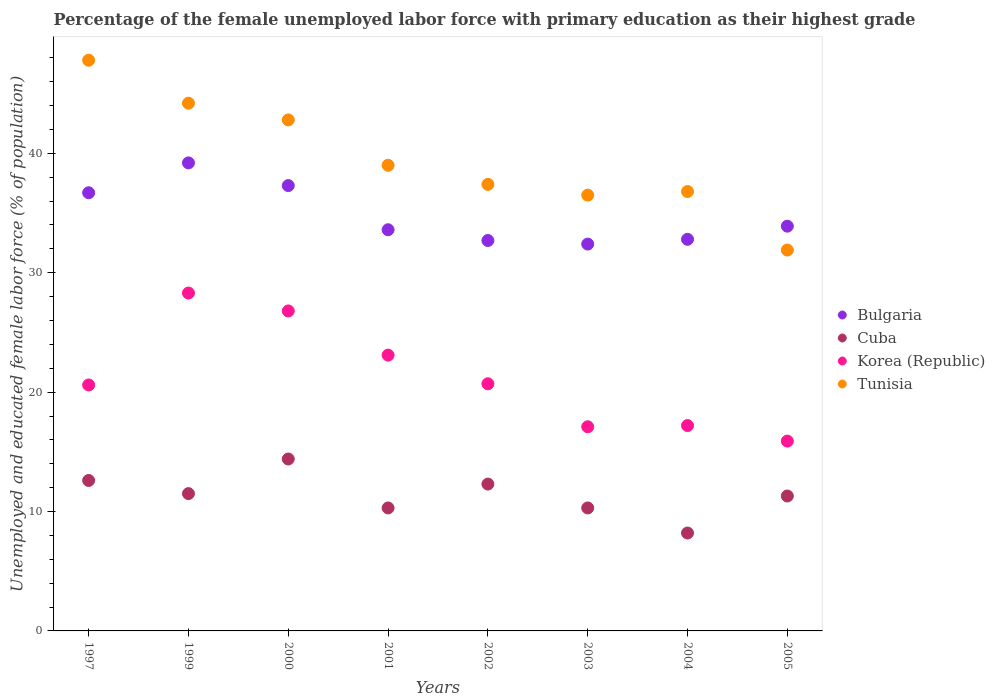Is the number of dotlines equal to the number of legend labels?
Your answer should be very brief. Yes. What is the percentage of the unemployed female labor force with primary education in Tunisia in 2003?
Your answer should be very brief. 36.5. Across all years, what is the maximum percentage of the unemployed female labor force with primary education in Cuba?
Keep it short and to the point. 14.4. Across all years, what is the minimum percentage of the unemployed female labor force with primary education in Bulgaria?
Give a very brief answer. 32.4. What is the total percentage of the unemployed female labor force with primary education in Bulgaria in the graph?
Offer a terse response. 278.6. What is the difference between the percentage of the unemployed female labor force with primary education in Bulgaria in 2004 and that in 2005?
Make the answer very short. -1.1. What is the average percentage of the unemployed female labor force with primary education in Korea (Republic) per year?
Give a very brief answer. 21.21. In the year 2005, what is the difference between the percentage of the unemployed female labor force with primary education in Cuba and percentage of the unemployed female labor force with primary education in Korea (Republic)?
Make the answer very short. -4.6. What is the ratio of the percentage of the unemployed female labor force with primary education in Korea (Republic) in 1999 to that in 2003?
Provide a succinct answer. 1.65. What is the difference between the highest and the second highest percentage of the unemployed female labor force with primary education in Cuba?
Make the answer very short. 1.8. What is the difference between the highest and the lowest percentage of the unemployed female labor force with primary education in Bulgaria?
Ensure brevity in your answer.  6.8. In how many years, is the percentage of the unemployed female labor force with primary education in Cuba greater than the average percentage of the unemployed female labor force with primary education in Cuba taken over all years?
Give a very brief answer. 4. Is it the case that in every year, the sum of the percentage of the unemployed female labor force with primary education in Korea (Republic) and percentage of the unemployed female labor force with primary education in Bulgaria  is greater than the sum of percentage of the unemployed female labor force with primary education in Tunisia and percentage of the unemployed female labor force with primary education in Cuba?
Your answer should be very brief. Yes. Is it the case that in every year, the sum of the percentage of the unemployed female labor force with primary education in Bulgaria and percentage of the unemployed female labor force with primary education in Tunisia  is greater than the percentage of the unemployed female labor force with primary education in Cuba?
Provide a short and direct response. Yes. Does the percentage of the unemployed female labor force with primary education in Bulgaria monotonically increase over the years?
Make the answer very short. No. Is the percentage of the unemployed female labor force with primary education in Cuba strictly greater than the percentage of the unemployed female labor force with primary education in Korea (Republic) over the years?
Make the answer very short. No. Is the percentage of the unemployed female labor force with primary education in Bulgaria strictly less than the percentage of the unemployed female labor force with primary education in Tunisia over the years?
Provide a short and direct response. No. How many dotlines are there?
Offer a very short reply. 4. How many years are there in the graph?
Give a very brief answer. 8. What is the difference between two consecutive major ticks on the Y-axis?
Keep it short and to the point. 10. Does the graph contain any zero values?
Provide a succinct answer. No. What is the title of the graph?
Give a very brief answer. Percentage of the female unemployed labor force with primary education as their highest grade. Does "Micronesia" appear as one of the legend labels in the graph?
Ensure brevity in your answer.  No. What is the label or title of the X-axis?
Ensure brevity in your answer.  Years. What is the label or title of the Y-axis?
Give a very brief answer. Unemployed and educated female labor force (% of population). What is the Unemployed and educated female labor force (% of population) of Bulgaria in 1997?
Make the answer very short. 36.7. What is the Unemployed and educated female labor force (% of population) of Cuba in 1997?
Offer a terse response. 12.6. What is the Unemployed and educated female labor force (% of population) of Korea (Republic) in 1997?
Your answer should be compact. 20.6. What is the Unemployed and educated female labor force (% of population) in Tunisia in 1997?
Offer a very short reply. 47.8. What is the Unemployed and educated female labor force (% of population) in Bulgaria in 1999?
Keep it short and to the point. 39.2. What is the Unemployed and educated female labor force (% of population) of Korea (Republic) in 1999?
Offer a very short reply. 28.3. What is the Unemployed and educated female labor force (% of population) in Tunisia in 1999?
Provide a short and direct response. 44.2. What is the Unemployed and educated female labor force (% of population) in Bulgaria in 2000?
Keep it short and to the point. 37.3. What is the Unemployed and educated female labor force (% of population) of Cuba in 2000?
Your answer should be very brief. 14.4. What is the Unemployed and educated female labor force (% of population) of Korea (Republic) in 2000?
Offer a very short reply. 26.8. What is the Unemployed and educated female labor force (% of population) in Tunisia in 2000?
Make the answer very short. 42.8. What is the Unemployed and educated female labor force (% of population) of Bulgaria in 2001?
Ensure brevity in your answer.  33.6. What is the Unemployed and educated female labor force (% of population) of Cuba in 2001?
Provide a short and direct response. 10.3. What is the Unemployed and educated female labor force (% of population) in Korea (Republic) in 2001?
Provide a short and direct response. 23.1. What is the Unemployed and educated female labor force (% of population) of Tunisia in 2001?
Make the answer very short. 39. What is the Unemployed and educated female labor force (% of population) of Bulgaria in 2002?
Keep it short and to the point. 32.7. What is the Unemployed and educated female labor force (% of population) in Cuba in 2002?
Keep it short and to the point. 12.3. What is the Unemployed and educated female labor force (% of population) of Korea (Republic) in 2002?
Provide a succinct answer. 20.7. What is the Unemployed and educated female labor force (% of population) of Tunisia in 2002?
Ensure brevity in your answer.  37.4. What is the Unemployed and educated female labor force (% of population) of Bulgaria in 2003?
Offer a terse response. 32.4. What is the Unemployed and educated female labor force (% of population) in Cuba in 2003?
Provide a short and direct response. 10.3. What is the Unemployed and educated female labor force (% of population) in Korea (Republic) in 2003?
Your answer should be very brief. 17.1. What is the Unemployed and educated female labor force (% of population) of Tunisia in 2003?
Offer a very short reply. 36.5. What is the Unemployed and educated female labor force (% of population) of Bulgaria in 2004?
Your answer should be very brief. 32.8. What is the Unemployed and educated female labor force (% of population) of Cuba in 2004?
Keep it short and to the point. 8.2. What is the Unemployed and educated female labor force (% of population) in Korea (Republic) in 2004?
Your answer should be compact. 17.2. What is the Unemployed and educated female labor force (% of population) of Tunisia in 2004?
Your answer should be compact. 36.8. What is the Unemployed and educated female labor force (% of population) of Bulgaria in 2005?
Make the answer very short. 33.9. What is the Unemployed and educated female labor force (% of population) in Cuba in 2005?
Make the answer very short. 11.3. What is the Unemployed and educated female labor force (% of population) of Korea (Republic) in 2005?
Offer a very short reply. 15.9. What is the Unemployed and educated female labor force (% of population) of Tunisia in 2005?
Your answer should be compact. 31.9. Across all years, what is the maximum Unemployed and educated female labor force (% of population) in Bulgaria?
Ensure brevity in your answer.  39.2. Across all years, what is the maximum Unemployed and educated female labor force (% of population) of Cuba?
Make the answer very short. 14.4. Across all years, what is the maximum Unemployed and educated female labor force (% of population) in Korea (Republic)?
Keep it short and to the point. 28.3. Across all years, what is the maximum Unemployed and educated female labor force (% of population) in Tunisia?
Your answer should be very brief. 47.8. Across all years, what is the minimum Unemployed and educated female labor force (% of population) in Bulgaria?
Give a very brief answer. 32.4. Across all years, what is the minimum Unemployed and educated female labor force (% of population) in Cuba?
Give a very brief answer. 8.2. Across all years, what is the minimum Unemployed and educated female labor force (% of population) of Korea (Republic)?
Your answer should be very brief. 15.9. Across all years, what is the minimum Unemployed and educated female labor force (% of population) of Tunisia?
Your response must be concise. 31.9. What is the total Unemployed and educated female labor force (% of population) in Bulgaria in the graph?
Keep it short and to the point. 278.6. What is the total Unemployed and educated female labor force (% of population) of Cuba in the graph?
Offer a terse response. 90.9. What is the total Unemployed and educated female labor force (% of population) of Korea (Republic) in the graph?
Your response must be concise. 169.7. What is the total Unemployed and educated female labor force (% of population) of Tunisia in the graph?
Your response must be concise. 316.4. What is the difference between the Unemployed and educated female labor force (% of population) in Cuba in 1997 and that in 1999?
Your answer should be compact. 1.1. What is the difference between the Unemployed and educated female labor force (% of population) of Korea (Republic) in 1997 and that in 1999?
Your answer should be compact. -7.7. What is the difference between the Unemployed and educated female labor force (% of population) of Tunisia in 1997 and that in 1999?
Offer a terse response. 3.6. What is the difference between the Unemployed and educated female labor force (% of population) in Bulgaria in 1997 and that in 2000?
Your answer should be compact. -0.6. What is the difference between the Unemployed and educated female labor force (% of population) in Cuba in 1997 and that in 2000?
Your response must be concise. -1.8. What is the difference between the Unemployed and educated female labor force (% of population) of Bulgaria in 1997 and that in 2001?
Offer a terse response. 3.1. What is the difference between the Unemployed and educated female labor force (% of population) in Cuba in 1997 and that in 2001?
Offer a very short reply. 2.3. What is the difference between the Unemployed and educated female labor force (% of population) of Bulgaria in 1997 and that in 2002?
Provide a succinct answer. 4. What is the difference between the Unemployed and educated female labor force (% of population) in Cuba in 1997 and that in 2002?
Offer a terse response. 0.3. What is the difference between the Unemployed and educated female labor force (% of population) in Bulgaria in 1997 and that in 2003?
Offer a very short reply. 4.3. What is the difference between the Unemployed and educated female labor force (% of population) of Cuba in 1997 and that in 2003?
Offer a terse response. 2.3. What is the difference between the Unemployed and educated female labor force (% of population) of Tunisia in 1997 and that in 2003?
Provide a short and direct response. 11.3. What is the difference between the Unemployed and educated female labor force (% of population) in Cuba in 1997 and that in 2004?
Your answer should be compact. 4.4. What is the difference between the Unemployed and educated female labor force (% of population) of Tunisia in 1997 and that in 2004?
Provide a short and direct response. 11. What is the difference between the Unemployed and educated female labor force (% of population) of Cuba in 1997 and that in 2005?
Ensure brevity in your answer.  1.3. What is the difference between the Unemployed and educated female labor force (% of population) of Korea (Republic) in 1997 and that in 2005?
Offer a terse response. 4.7. What is the difference between the Unemployed and educated female labor force (% of population) of Tunisia in 1997 and that in 2005?
Make the answer very short. 15.9. What is the difference between the Unemployed and educated female labor force (% of population) of Tunisia in 1999 and that in 2000?
Your response must be concise. 1.4. What is the difference between the Unemployed and educated female labor force (% of population) of Bulgaria in 1999 and that in 2001?
Provide a short and direct response. 5.6. What is the difference between the Unemployed and educated female labor force (% of population) of Tunisia in 1999 and that in 2001?
Your answer should be very brief. 5.2. What is the difference between the Unemployed and educated female labor force (% of population) in Bulgaria in 1999 and that in 2002?
Your answer should be very brief. 6.5. What is the difference between the Unemployed and educated female labor force (% of population) in Tunisia in 1999 and that in 2002?
Your response must be concise. 6.8. What is the difference between the Unemployed and educated female labor force (% of population) of Bulgaria in 1999 and that in 2003?
Your response must be concise. 6.8. What is the difference between the Unemployed and educated female labor force (% of population) in Korea (Republic) in 1999 and that in 2003?
Make the answer very short. 11.2. What is the difference between the Unemployed and educated female labor force (% of population) of Cuba in 1999 and that in 2004?
Provide a short and direct response. 3.3. What is the difference between the Unemployed and educated female labor force (% of population) of Korea (Republic) in 1999 and that in 2004?
Offer a terse response. 11.1. What is the difference between the Unemployed and educated female labor force (% of population) of Tunisia in 1999 and that in 2004?
Provide a succinct answer. 7.4. What is the difference between the Unemployed and educated female labor force (% of population) in Bulgaria in 1999 and that in 2005?
Keep it short and to the point. 5.3. What is the difference between the Unemployed and educated female labor force (% of population) of Tunisia in 1999 and that in 2005?
Make the answer very short. 12.3. What is the difference between the Unemployed and educated female labor force (% of population) in Cuba in 2000 and that in 2001?
Your answer should be very brief. 4.1. What is the difference between the Unemployed and educated female labor force (% of population) of Korea (Republic) in 2000 and that in 2001?
Ensure brevity in your answer.  3.7. What is the difference between the Unemployed and educated female labor force (% of population) in Tunisia in 2000 and that in 2001?
Your response must be concise. 3.8. What is the difference between the Unemployed and educated female labor force (% of population) in Cuba in 2000 and that in 2002?
Give a very brief answer. 2.1. What is the difference between the Unemployed and educated female labor force (% of population) in Korea (Republic) in 2000 and that in 2002?
Provide a short and direct response. 6.1. What is the difference between the Unemployed and educated female labor force (% of population) in Tunisia in 2000 and that in 2002?
Give a very brief answer. 5.4. What is the difference between the Unemployed and educated female labor force (% of population) of Bulgaria in 2000 and that in 2003?
Give a very brief answer. 4.9. What is the difference between the Unemployed and educated female labor force (% of population) of Cuba in 2000 and that in 2003?
Provide a short and direct response. 4.1. What is the difference between the Unemployed and educated female labor force (% of population) in Cuba in 2000 and that in 2004?
Offer a terse response. 6.2. What is the difference between the Unemployed and educated female labor force (% of population) in Korea (Republic) in 2000 and that in 2004?
Your answer should be compact. 9.6. What is the difference between the Unemployed and educated female labor force (% of population) in Bulgaria in 2000 and that in 2005?
Ensure brevity in your answer.  3.4. What is the difference between the Unemployed and educated female labor force (% of population) of Korea (Republic) in 2000 and that in 2005?
Keep it short and to the point. 10.9. What is the difference between the Unemployed and educated female labor force (% of population) of Cuba in 2001 and that in 2002?
Keep it short and to the point. -2. What is the difference between the Unemployed and educated female labor force (% of population) of Korea (Republic) in 2001 and that in 2002?
Provide a succinct answer. 2.4. What is the difference between the Unemployed and educated female labor force (% of population) in Tunisia in 2001 and that in 2002?
Offer a very short reply. 1.6. What is the difference between the Unemployed and educated female labor force (% of population) of Cuba in 2001 and that in 2003?
Make the answer very short. 0. What is the difference between the Unemployed and educated female labor force (% of population) of Tunisia in 2001 and that in 2003?
Offer a terse response. 2.5. What is the difference between the Unemployed and educated female labor force (% of population) of Tunisia in 2001 and that in 2004?
Give a very brief answer. 2.2. What is the difference between the Unemployed and educated female labor force (% of population) in Korea (Republic) in 2001 and that in 2005?
Ensure brevity in your answer.  7.2. What is the difference between the Unemployed and educated female labor force (% of population) in Cuba in 2002 and that in 2003?
Ensure brevity in your answer.  2. What is the difference between the Unemployed and educated female labor force (% of population) of Korea (Republic) in 2002 and that in 2003?
Ensure brevity in your answer.  3.6. What is the difference between the Unemployed and educated female labor force (% of population) in Bulgaria in 2002 and that in 2004?
Ensure brevity in your answer.  -0.1. What is the difference between the Unemployed and educated female labor force (% of population) in Korea (Republic) in 2002 and that in 2004?
Offer a very short reply. 3.5. What is the difference between the Unemployed and educated female labor force (% of population) in Bulgaria in 2003 and that in 2004?
Make the answer very short. -0.4. What is the difference between the Unemployed and educated female labor force (% of population) in Korea (Republic) in 2003 and that in 2004?
Give a very brief answer. -0.1. What is the difference between the Unemployed and educated female labor force (% of population) of Cuba in 2004 and that in 2005?
Provide a succinct answer. -3.1. What is the difference between the Unemployed and educated female labor force (% of population) in Korea (Republic) in 2004 and that in 2005?
Offer a very short reply. 1.3. What is the difference between the Unemployed and educated female labor force (% of population) of Tunisia in 2004 and that in 2005?
Your answer should be compact. 4.9. What is the difference between the Unemployed and educated female labor force (% of population) in Bulgaria in 1997 and the Unemployed and educated female labor force (% of population) in Cuba in 1999?
Give a very brief answer. 25.2. What is the difference between the Unemployed and educated female labor force (% of population) in Bulgaria in 1997 and the Unemployed and educated female labor force (% of population) in Korea (Republic) in 1999?
Ensure brevity in your answer.  8.4. What is the difference between the Unemployed and educated female labor force (% of population) of Bulgaria in 1997 and the Unemployed and educated female labor force (% of population) of Tunisia in 1999?
Keep it short and to the point. -7.5. What is the difference between the Unemployed and educated female labor force (% of population) in Cuba in 1997 and the Unemployed and educated female labor force (% of population) in Korea (Republic) in 1999?
Offer a very short reply. -15.7. What is the difference between the Unemployed and educated female labor force (% of population) in Cuba in 1997 and the Unemployed and educated female labor force (% of population) in Tunisia in 1999?
Offer a very short reply. -31.6. What is the difference between the Unemployed and educated female labor force (% of population) of Korea (Republic) in 1997 and the Unemployed and educated female labor force (% of population) of Tunisia in 1999?
Keep it short and to the point. -23.6. What is the difference between the Unemployed and educated female labor force (% of population) of Bulgaria in 1997 and the Unemployed and educated female labor force (% of population) of Cuba in 2000?
Make the answer very short. 22.3. What is the difference between the Unemployed and educated female labor force (% of population) of Bulgaria in 1997 and the Unemployed and educated female labor force (% of population) of Korea (Republic) in 2000?
Provide a succinct answer. 9.9. What is the difference between the Unemployed and educated female labor force (% of population) in Bulgaria in 1997 and the Unemployed and educated female labor force (% of population) in Tunisia in 2000?
Offer a very short reply. -6.1. What is the difference between the Unemployed and educated female labor force (% of population) of Cuba in 1997 and the Unemployed and educated female labor force (% of population) of Korea (Republic) in 2000?
Your answer should be compact. -14.2. What is the difference between the Unemployed and educated female labor force (% of population) of Cuba in 1997 and the Unemployed and educated female labor force (% of population) of Tunisia in 2000?
Provide a succinct answer. -30.2. What is the difference between the Unemployed and educated female labor force (% of population) in Korea (Republic) in 1997 and the Unemployed and educated female labor force (% of population) in Tunisia in 2000?
Provide a succinct answer. -22.2. What is the difference between the Unemployed and educated female labor force (% of population) of Bulgaria in 1997 and the Unemployed and educated female labor force (% of population) of Cuba in 2001?
Your response must be concise. 26.4. What is the difference between the Unemployed and educated female labor force (% of population) of Bulgaria in 1997 and the Unemployed and educated female labor force (% of population) of Korea (Republic) in 2001?
Give a very brief answer. 13.6. What is the difference between the Unemployed and educated female labor force (% of population) in Cuba in 1997 and the Unemployed and educated female labor force (% of population) in Tunisia in 2001?
Provide a short and direct response. -26.4. What is the difference between the Unemployed and educated female labor force (% of population) in Korea (Republic) in 1997 and the Unemployed and educated female labor force (% of population) in Tunisia in 2001?
Ensure brevity in your answer.  -18.4. What is the difference between the Unemployed and educated female labor force (% of population) of Bulgaria in 1997 and the Unemployed and educated female labor force (% of population) of Cuba in 2002?
Your response must be concise. 24.4. What is the difference between the Unemployed and educated female labor force (% of population) in Bulgaria in 1997 and the Unemployed and educated female labor force (% of population) in Korea (Republic) in 2002?
Make the answer very short. 16. What is the difference between the Unemployed and educated female labor force (% of population) of Cuba in 1997 and the Unemployed and educated female labor force (% of population) of Korea (Republic) in 2002?
Keep it short and to the point. -8.1. What is the difference between the Unemployed and educated female labor force (% of population) in Cuba in 1997 and the Unemployed and educated female labor force (% of population) in Tunisia in 2002?
Provide a succinct answer. -24.8. What is the difference between the Unemployed and educated female labor force (% of population) in Korea (Republic) in 1997 and the Unemployed and educated female labor force (% of population) in Tunisia in 2002?
Your response must be concise. -16.8. What is the difference between the Unemployed and educated female labor force (% of population) in Bulgaria in 1997 and the Unemployed and educated female labor force (% of population) in Cuba in 2003?
Ensure brevity in your answer.  26.4. What is the difference between the Unemployed and educated female labor force (% of population) of Bulgaria in 1997 and the Unemployed and educated female labor force (% of population) of Korea (Republic) in 2003?
Your response must be concise. 19.6. What is the difference between the Unemployed and educated female labor force (% of population) of Cuba in 1997 and the Unemployed and educated female labor force (% of population) of Tunisia in 2003?
Provide a short and direct response. -23.9. What is the difference between the Unemployed and educated female labor force (% of population) in Korea (Republic) in 1997 and the Unemployed and educated female labor force (% of population) in Tunisia in 2003?
Give a very brief answer. -15.9. What is the difference between the Unemployed and educated female labor force (% of population) in Bulgaria in 1997 and the Unemployed and educated female labor force (% of population) in Cuba in 2004?
Offer a very short reply. 28.5. What is the difference between the Unemployed and educated female labor force (% of population) in Bulgaria in 1997 and the Unemployed and educated female labor force (% of population) in Korea (Republic) in 2004?
Provide a short and direct response. 19.5. What is the difference between the Unemployed and educated female labor force (% of population) of Bulgaria in 1997 and the Unemployed and educated female labor force (% of population) of Tunisia in 2004?
Provide a short and direct response. -0.1. What is the difference between the Unemployed and educated female labor force (% of population) in Cuba in 1997 and the Unemployed and educated female labor force (% of population) in Tunisia in 2004?
Ensure brevity in your answer.  -24.2. What is the difference between the Unemployed and educated female labor force (% of population) of Korea (Republic) in 1997 and the Unemployed and educated female labor force (% of population) of Tunisia in 2004?
Provide a short and direct response. -16.2. What is the difference between the Unemployed and educated female labor force (% of population) in Bulgaria in 1997 and the Unemployed and educated female labor force (% of population) in Cuba in 2005?
Your answer should be very brief. 25.4. What is the difference between the Unemployed and educated female labor force (% of population) in Bulgaria in 1997 and the Unemployed and educated female labor force (% of population) in Korea (Republic) in 2005?
Keep it short and to the point. 20.8. What is the difference between the Unemployed and educated female labor force (% of population) in Cuba in 1997 and the Unemployed and educated female labor force (% of population) in Tunisia in 2005?
Keep it short and to the point. -19.3. What is the difference between the Unemployed and educated female labor force (% of population) of Bulgaria in 1999 and the Unemployed and educated female labor force (% of population) of Cuba in 2000?
Your response must be concise. 24.8. What is the difference between the Unemployed and educated female labor force (% of population) of Bulgaria in 1999 and the Unemployed and educated female labor force (% of population) of Tunisia in 2000?
Your answer should be very brief. -3.6. What is the difference between the Unemployed and educated female labor force (% of population) of Cuba in 1999 and the Unemployed and educated female labor force (% of population) of Korea (Republic) in 2000?
Your answer should be very brief. -15.3. What is the difference between the Unemployed and educated female labor force (% of population) in Cuba in 1999 and the Unemployed and educated female labor force (% of population) in Tunisia in 2000?
Keep it short and to the point. -31.3. What is the difference between the Unemployed and educated female labor force (% of population) of Korea (Republic) in 1999 and the Unemployed and educated female labor force (% of population) of Tunisia in 2000?
Your answer should be very brief. -14.5. What is the difference between the Unemployed and educated female labor force (% of population) of Bulgaria in 1999 and the Unemployed and educated female labor force (% of population) of Cuba in 2001?
Make the answer very short. 28.9. What is the difference between the Unemployed and educated female labor force (% of population) of Bulgaria in 1999 and the Unemployed and educated female labor force (% of population) of Korea (Republic) in 2001?
Provide a short and direct response. 16.1. What is the difference between the Unemployed and educated female labor force (% of population) of Cuba in 1999 and the Unemployed and educated female labor force (% of population) of Tunisia in 2001?
Make the answer very short. -27.5. What is the difference between the Unemployed and educated female labor force (% of population) of Korea (Republic) in 1999 and the Unemployed and educated female labor force (% of population) of Tunisia in 2001?
Ensure brevity in your answer.  -10.7. What is the difference between the Unemployed and educated female labor force (% of population) of Bulgaria in 1999 and the Unemployed and educated female labor force (% of population) of Cuba in 2002?
Your answer should be compact. 26.9. What is the difference between the Unemployed and educated female labor force (% of population) of Bulgaria in 1999 and the Unemployed and educated female labor force (% of population) of Korea (Republic) in 2002?
Provide a short and direct response. 18.5. What is the difference between the Unemployed and educated female labor force (% of population) in Bulgaria in 1999 and the Unemployed and educated female labor force (% of population) in Tunisia in 2002?
Provide a short and direct response. 1.8. What is the difference between the Unemployed and educated female labor force (% of population) of Cuba in 1999 and the Unemployed and educated female labor force (% of population) of Tunisia in 2002?
Keep it short and to the point. -25.9. What is the difference between the Unemployed and educated female labor force (% of population) of Korea (Republic) in 1999 and the Unemployed and educated female labor force (% of population) of Tunisia in 2002?
Your response must be concise. -9.1. What is the difference between the Unemployed and educated female labor force (% of population) in Bulgaria in 1999 and the Unemployed and educated female labor force (% of population) in Cuba in 2003?
Ensure brevity in your answer.  28.9. What is the difference between the Unemployed and educated female labor force (% of population) of Bulgaria in 1999 and the Unemployed and educated female labor force (% of population) of Korea (Republic) in 2003?
Your answer should be compact. 22.1. What is the difference between the Unemployed and educated female labor force (% of population) of Bulgaria in 1999 and the Unemployed and educated female labor force (% of population) of Tunisia in 2003?
Offer a terse response. 2.7. What is the difference between the Unemployed and educated female labor force (% of population) of Cuba in 1999 and the Unemployed and educated female labor force (% of population) of Korea (Republic) in 2003?
Your answer should be compact. -5.6. What is the difference between the Unemployed and educated female labor force (% of population) of Korea (Republic) in 1999 and the Unemployed and educated female labor force (% of population) of Tunisia in 2003?
Your answer should be very brief. -8.2. What is the difference between the Unemployed and educated female labor force (% of population) of Cuba in 1999 and the Unemployed and educated female labor force (% of population) of Tunisia in 2004?
Make the answer very short. -25.3. What is the difference between the Unemployed and educated female labor force (% of population) of Bulgaria in 1999 and the Unemployed and educated female labor force (% of population) of Cuba in 2005?
Your response must be concise. 27.9. What is the difference between the Unemployed and educated female labor force (% of population) in Bulgaria in 1999 and the Unemployed and educated female labor force (% of population) in Korea (Republic) in 2005?
Your answer should be compact. 23.3. What is the difference between the Unemployed and educated female labor force (% of population) in Cuba in 1999 and the Unemployed and educated female labor force (% of population) in Korea (Republic) in 2005?
Your answer should be compact. -4.4. What is the difference between the Unemployed and educated female labor force (% of population) of Cuba in 1999 and the Unemployed and educated female labor force (% of population) of Tunisia in 2005?
Keep it short and to the point. -20.4. What is the difference between the Unemployed and educated female labor force (% of population) of Korea (Republic) in 1999 and the Unemployed and educated female labor force (% of population) of Tunisia in 2005?
Your answer should be very brief. -3.6. What is the difference between the Unemployed and educated female labor force (% of population) of Bulgaria in 2000 and the Unemployed and educated female labor force (% of population) of Korea (Republic) in 2001?
Offer a very short reply. 14.2. What is the difference between the Unemployed and educated female labor force (% of population) of Cuba in 2000 and the Unemployed and educated female labor force (% of population) of Tunisia in 2001?
Keep it short and to the point. -24.6. What is the difference between the Unemployed and educated female labor force (% of population) in Bulgaria in 2000 and the Unemployed and educated female labor force (% of population) in Korea (Republic) in 2002?
Provide a short and direct response. 16.6. What is the difference between the Unemployed and educated female labor force (% of population) in Bulgaria in 2000 and the Unemployed and educated female labor force (% of population) in Tunisia in 2002?
Offer a terse response. -0.1. What is the difference between the Unemployed and educated female labor force (% of population) of Korea (Republic) in 2000 and the Unemployed and educated female labor force (% of population) of Tunisia in 2002?
Provide a short and direct response. -10.6. What is the difference between the Unemployed and educated female labor force (% of population) in Bulgaria in 2000 and the Unemployed and educated female labor force (% of population) in Korea (Republic) in 2003?
Your answer should be compact. 20.2. What is the difference between the Unemployed and educated female labor force (% of population) of Cuba in 2000 and the Unemployed and educated female labor force (% of population) of Korea (Republic) in 2003?
Your answer should be very brief. -2.7. What is the difference between the Unemployed and educated female labor force (% of population) in Cuba in 2000 and the Unemployed and educated female labor force (% of population) in Tunisia in 2003?
Ensure brevity in your answer.  -22.1. What is the difference between the Unemployed and educated female labor force (% of population) of Korea (Republic) in 2000 and the Unemployed and educated female labor force (% of population) of Tunisia in 2003?
Offer a terse response. -9.7. What is the difference between the Unemployed and educated female labor force (% of population) in Bulgaria in 2000 and the Unemployed and educated female labor force (% of population) in Cuba in 2004?
Make the answer very short. 29.1. What is the difference between the Unemployed and educated female labor force (% of population) of Bulgaria in 2000 and the Unemployed and educated female labor force (% of population) of Korea (Republic) in 2004?
Your answer should be very brief. 20.1. What is the difference between the Unemployed and educated female labor force (% of population) in Cuba in 2000 and the Unemployed and educated female labor force (% of population) in Tunisia in 2004?
Provide a short and direct response. -22.4. What is the difference between the Unemployed and educated female labor force (% of population) in Bulgaria in 2000 and the Unemployed and educated female labor force (% of population) in Korea (Republic) in 2005?
Make the answer very short. 21.4. What is the difference between the Unemployed and educated female labor force (% of population) of Cuba in 2000 and the Unemployed and educated female labor force (% of population) of Korea (Republic) in 2005?
Ensure brevity in your answer.  -1.5. What is the difference between the Unemployed and educated female labor force (% of population) of Cuba in 2000 and the Unemployed and educated female labor force (% of population) of Tunisia in 2005?
Offer a terse response. -17.5. What is the difference between the Unemployed and educated female labor force (% of population) in Korea (Republic) in 2000 and the Unemployed and educated female labor force (% of population) in Tunisia in 2005?
Provide a succinct answer. -5.1. What is the difference between the Unemployed and educated female labor force (% of population) of Bulgaria in 2001 and the Unemployed and educated female labor force (% of population) of Cuba in 2002?
Keep it short and to the point. 21.3. What is the difference between the Unemployed and educated female labor force (% of population) in Cuba in 2001 and the Unemployed and educated female labor force (% of population) in Tunisia in 2002?
Provide a short and direct response. -27.1. What is the difference between the Unemployed and educated female labor force (% of population) in Korea (Republic) in 2001 and the Unemployed and educated female labor force (% of population) in Tunisia in 2002?
Offer a terse response. -14.3. What is the difference between the Unemployed and educated female labor force (% of population) of Bulgaria in 2001 and the Unemployed and educated female labor force (% of population) of Cuba in 2003?
Give a very brief answer. 23.3. What is the difference between the Unemployed and educated female labor force (% of population) in Bulgaria in 2001 and the Unemployed and educated female labor force (% of population) in Korea (Republic) in 2003?
Your answer should be very brief. 16.5. What is the difference between the Unemployed and educated female labor force (% of population) in Cuba in 2001 and the Unemployed and educated female labor force (% of population) in Korea (Republic) in 2003?
Offer a very short reply. -6.8. What is the difference between the Unemployed and educated female labor force (% of population) in Cuba in 2001 and the Unemployed and educated female labor force (% of population) in Tunisia in 2003?
Give a very brief answer. -26.2. What is the difference between the Unemployed and educated female labor force (% of population) of Bulgaria in 2001 and the Unemployed and educated female labor force (% of population) of Cuba in 2004?
Provide a short and direct response. 25.4. What is the difference between the Unemployed and educated female labor force (% of population) in Bulgaria in 2001 and the Unemployed and educated female labor force (% of population) in Korea (Republic) in 2004?
Keep it short and to the point. 16.4. What is the difference between the Unemployed and educated female labor force (% of population) of Bulgaria in 2001 and the Unemployed and educated female labor force (% of population) of Tunisia in 2004?
Ensure brevity in your answer.  -3.2. What is the difference between the Unemployed and educated female labor force (% of population) of Cuba in 2001 and the Unemployed and educated female labor force (% of population) of Tunisia in 2004?
Make the answer very short. -26.5. What is the difference between the Unemployed and educated female labor force (% of population) of Korea (Republic) in 2001 and the Unemployed and educated female labor force (% of population) of Tunisia in 2004?
Offer a terse response. -13.7. What is the difference between the Unemployed and educated female labor force (% of population) in Bulgaria in 2001 and the Unemployed and educated female labor force (% of population) in Cuba in 2005?
Your response must be concise. 22.3. What is the difference between the Unemployed and educated female labor force (% of population) in Bulgaria in 2001 and the Unemployed and educated female labor force (% of population) in Korea (Republic) in 2005?
Offer a terse response. 17.7. What is the difference between the Unemployed and educated female labor force (% of population) in Bulgaria in 2001 and the Unemployed and educated female labor force (% of population) in Tunisia in 2005?
Provide a short and direct response. 1.7. What is the difference between the Unemployed and educated female labor force (% of population) of Cuba in 2001 and the Unemployed and educated female labor force (% of population) of Korea (Republic) in 2005?
Offer a very short reply. -5.6. What is the difference between the Unemployed and educated female labor force (% of population) of Cuba in 2001 and the Unemployed and educated female labor force (% of population) of Tunisia in 2005?
Ensure brevity in your answer.  -21.6. What is the difference between the Unemployed and educated female labor force (% of population) in Korea (Republic) in 2001 and the Unemployed and educated female labor force (% of population) in Tunisia in 2005?
Your answer should be very brief. -8.8. What is the difference between the Unemployed and educated female labor force (% of population) in Bulgaria in 2002 and the Unemployed and educated female labor force (% of population) in Cuba in 2003?
Keep it short and to the point. 22.4. What is the difference between the Unemployed and educated female labor force (% of population) of Bulgaria in 2002 and the Unemployed and educated female labor force (% of population) of Tunisia in 2003?
Offer a terse response. -3.8. What is the difference between the Unemployed and educated female labor force (% of population) of Cuba in 2002 and the Unemployed and educated female labor force (% of population) of Tunisia in 2003?
Make the answer very short. -24.2. What is the difference between the Unemployed and educated female labor force (% of population) of Korea (Republic) in 2002 and the Unemployed and educated female labor force (% of population) of Tunisia in 2003?
Your answer should be very brief. -15.8. What is the difference between the Unemployed and educated female labor force (% of population) of Bulgaria in 2002 and the Unemployed and educated female labor force (% of population) of Korea (Republic) in 2004?
Provide a short and direct response. 15.5. What is the difference between the Unemployed and educated female labor force (% of population) in Bulgaria in 2002 and the Unemployed and educated female labor force (% of population) in Tunisia in 2004?
Offer a very short reply. -4.1. What is the difference between the Unemployed and educated female labor force (% of population) of Cuba in 2002 and the Unemployed and educated female labor force (% of population) of Tunisia in 2004?
Provide a short and direct response. -24.5. What is the difference between the Unemployed and educated female labor force (% of population) in Korea (Republic) in 2002 and the Unemployed and educated female labor force (% of population) in Tunisia in 2004?
Give a very brief answer. -16.1. What is the difference between the Unemployed and educated female labor force (% of population) of Bulgaria in 2002 and the Unemployed and educated female labor force (% of population) of Cuba in 2005?
Keep it short and to the point. 21.4. What is the difference between the Unemployed and educated female labor force (% of population) in Bulgaria in 2002 and the Unemployed and educated female labor force (% of population) in Korea (Republic) in 2005?
Provide a succinct answer. 16.8. What is the difference between the Unemployed and educated female labor force (% of population) in Cuba in 2002 and the Unemployed and educated female labor force (% of population) in Tunisia in 2005?
Provide a short and direct response. -19.6. What is the difference between the Unemployed and educated female labor force (% of population) of Bulgaria in 2003 and the Unemployed and educated female labor force (% of population) of Cuba in 2004?
Provide a succinct answer. 24.2. What is the difference between the Unemployed and educated female labor force (% of population) of Cuba in 2003 and the Unemployed and educated female labor force (% of population) of Tunisia in 2004?
Give a very brief answer. -26.5. What is the difference between the Unemployed and educated female labor force (% of population) in Korea (Republic) in 2003 and the Unemployed and educated female labor force (% of population) in Tunisia in 2004?
Offer a very short reply. -19.7. What is the difference between the Unemployed and educated female labor force (% of population) in Bulgaria in 2003 and the Unemployed and educated female labor force (% of population) in Cuba in 2005?
Keep it short and to the point. 21.1. What is the difference between the Unemployed and educated female labor force (% of population) in Cuba in 2003 and the Unemployed and educated female labor force (% of population) in Korea (Republic) in 2005?
Provide a short and direct response. -5.6. What is the difference between the Unemployed and educated female labor force (% of population) of Cuba in 2003 and the Unemployed and educated female labor force (% of population) of Tunisia in 2005?
Provide a short and direct response. -21.6. What is the difference between the Unemployed and educated female labor force (% of population) in Korea (Republic) in 2003 and the Unemployed and educated female labor force (% of population) in Tunisia in 2005?
Offer a terse response. -14.8. What is the difference between the Unemployed and educated female labor force (% of population) of Bulgaria in 2004 and the Unemployed and educated female labor force (% of population) of Tunisia in 2005?
Your answer should be very brief. 0.9. What is the difference between the Unemployed and educated female labor force (% of population) of Cuba in 2004 and the Unemployed and educated female labor force (% of population) of Korea (Republic) in 2005?
Provide a succinct answer. -7.7. What is the difference between the Unemployed and educated female labor force (% of population) in Cuba in 2004 and the Unemployed and educated female labor force (% of population) in Tunisia in 2005?
Give a very brief answer. -23.7. What is the difference between the Unemployed and educated female labor force (% of population) of Korea (Republic) in 2004 and the Unemployed and educated female labor force (% of population) of Tunisia in 2005?
Make the answer very short. -14.7. What is the average Unemployed and educated female labor force (% of population) in Bulgaria per year?
Make the answer very short. 34.83. What is the average Unemployed and educated female labor force (% of population) of Cuba per year?
Your response must be concise. 11.36. What is the average Unemployed and educated female labor force (% of population) in Korea (Republic) per year?
Provide a succinct answer. 21.21. What is the average Unemployed and educated female labor force (% of population) of Tunisia per year?
Make the answer very short. 39.55. In the year 1997, what is the difference between the Unemployed and educated female labor force (% of population) of Bulgaria and Unemployed and educated female labor force (% of population) of Cuba?
Give a very brief answer. 24.1. In the year 1997, what is the difference between the Unemployed and educated female labor force (% of population) of Bulgaria and Unemployed and educated female labor force (% of population) of Korea (Republic)?
Give a very brief answer. 16.1. In the year 1997, what is the difference between the Unemployed and educated female labor force (% of population) of Cuba and Unemployed and educated female labor force (% of population) of Tunisia?
Your answer should be very brief. -35.2. In the year 1997, what is the difference between the Unemployed and educated female labor force (% of population) in Korea (Republic) and Unemployed and educated female labor force (% of population) in Tunisia?
Give a very brief answer. -27.2. In the year 1999, what is the difference between the Unemployed and educated female labor force (% of population) in Bulgaria and Unemployed and educated female labor force (% of population) in Cuba?
Your answer should be compact. 27.7. In the year 1999, what is the difference between the Unemployed and educated female labor force (% of population) in Bulgaria and Unemployed and educated female labor force (% of population) in Korea (Republic)?
Keep it short and to the point. 10.9. In the year 1999, what is the difference between the Unemployed and educated female labor force (% of population) in Cuba and Unemployed and educated female labor force (% of population) in Korea (Republic)?
Offer a very short reply. -16.8. In the year 1999, what is the difference between the Unemployed and educated female labor force (% of population) of Cuba and Unemployed and educated female labor force (% of population) of Tunisia?
Your answer should be very brief. -32.7. In the year 1999, what is the difference between the Unemployed and educated female labor force (% of population) in Korea (Republic) and Unemployed and educated female labor force (% of population) in Tunisia?
Give a very brief answer. -15.9. In the year 2000, what is the difference between the Unemployed and educated female labor force (% of population) of Bulgaria and Unemployed and educated female labor force (% of population) of Cuba?
Ensure brevity in your answer.  22.9. In the year 2000, what is the difference between the Unemployed and educated female labor force (% of population) of Bulgaria and Unemployed and educated female labor force (% of population) of Korea (Republic)?
Ensure brevity in your answer.  10.5. In the year 2000, what is the difference between the Unemployed and educated female labor force (% of population) in Cuba and Unemployed and educated female labor force (% of population) in Korea (Republic)?
Your answer should be compact. -12.4. In the year 2000, what is the difference between the Unemployed and educated female labor force (% of population) in Cuba and Unemployed and educated female labor force (% of population) in Tunisia?
Offer a terse response. -28.4. In the year 2001, what is the difference between the Unemployed and educated female labor force (% of population) of Bulgaria and Unemployed and educated female labor force (% of population) of Cuba?
Your answer should be very brief. 23.3. In the year 2001, what is the difference between the Unemployed and educated female labor force (% of population) of Bulgaria and Unemployed and educated female labor force (% of population) of Tunisia?
Offer a very short reply. -5.4. In the year 2001, what is the difference between the Unemployed and educated female labor force (% of population) in Cuba and Unemployed and educated female labor force (% of population) in Korea (Republic)?
Your response must be concise. -12.8. In the year 2001, what is the difference between the Unemployed and educated female labor force (% of population) in Cuba and Unemployed and educated female labor force (% of population) in Tunisia?
Offer a very short reply. -28.7. In the year 2001, what is the difference between the Unemployed and educated female labor force (% of population) in Korea (Republic) and Unemployed and educated female labor force (% of population) in Tunisia?
Offer a very short reply. -15.9. In the year 2002, what is the difference between the Unemployed and educated female labor force (% of population) in Bulgaria and Unemployed and educated female labor force (% of population) in Cuba?
Provide a succinct answer. 20.4. In the year 2002, what is the difference between the Unemployed and educated female labor force (% of population) in Bulgaria and Unemployed and educated female labor force (% of population) in Tunisia?
Ensure brevity in your answer.  -4.7. In the year 2002, what is the difference between the Unemployed and educated female labor force (% of population) of Cuba and Unemployed and educated female labor force (% of population) of Tunisia?
Provide a short and direct response. -25.1. In the year 2002, what is the difference between the Unemployed and educated female labor force (% of population) of Korea (Republic) and Unemployed and educated female labor force (% of population) of Tunisia?
Your answer should be very brief. -16.7. In the year 2003, what is the difference between the Unemployed and educated female labor force (% of population) in Bulgaria and Unemployed and educated female labor force (% of population) in Cuba?
Offer a terse response. 22.1. In the year 2003, what is the difference between the Unemployed and educated female labor force (% of population) of Bulgaria and Unemployed and educated female labor force (% of population) of Korea (Republic)?
Your answer should be compact. 15.3. In the year 2003, what is the difference between the Unemployed and educated female labor force (% of population) in Bulgaria and Unemployed and educated female labor force (% of population) in Tunisia?
Your response must be concise. -4.1. In the year 2003, what is the difference between the Unemployed and educated female labor force (% of population) in Cuba and Unemployed and educated female labor force (% of population) in Korea (Republic)?
Ensure brevity in your answer.  -6.8. In the year 2003, what is the difference between the Unemployed and educated female labor force (% of population) in Cuba and Unemployed and educated female labor force (% of population) in Tunisia?
Offer a terse response. -26.2. In the year 2003, what is the difference between the Unemployed and educated female labor force (% of population) of Korea (Republic) and Unemployed and educated female labor force (% of population) of Tunisia?
Make the answer very short. -19.4. In the year 2004, what is the difference between the Unemployed and educated female labor force (% of population) of Bulgaria and Unemployed and educated female labor force (% of population) of Cuba?
Provide a succinct answer. 24.6. In the year 2004, what is the difference between the Unemployed and educated female labor force (% of population) of Bulgaria and Unemployed and educated female labor force (% of population) of Tunisia?
Your response must be concise. -4. In the year 2004, what is the difference between the Unemployed and educated female labor force (% of population) in Cuba and Unemployed and educated female labor force (% of population) in Tunisia?
Provide a succinct answer. -28.6. In the year 2004, what is the difference between the Unemployed and educated female labor force (% of population) of Korea (Republic) and Unemployed and educated female labor force (% of population) of Tunisia?
Your answer should be compact. -19.6. In the year 2005, what is the difference between the Unemployed and educated female labor force (% of population) of Bulgaria and Unemployed and educated female labor force (% of population) of Cuba?
Make the answer very short. 22.6. In the year 2005, what is the difference between the Unemployed and educated female labor force (% of population) of Bulgaria and Unemployed and educated female labor force (% of population) of Korea (Republic)?
Offer a very short reply. 18. In the year 2005, what is the difference between the Unemployed and educated female labor force (% of population) in Cuba and Unemployed and educated female labor force (% of population) in Korea (Republic)?
Ensure brevity in your answer.  -4.6. In the year 2005, what is the difference between the Unemployed and educated female labor force (% of population) of Cuba and Unemployed and educated female labor force (% of population) of Tunisia?
Your answer should be very brief. -20.6. In the year 2005, what is the difference between the Unemployed and educated female labor force (% of population) in Korea (Republic) and Unemployed and educated female labor force (% of population) in Tunisia?
Give a very brief answer. -16. What is the ratio of the Unemployed and educated female labor force (% of population) of Bulgaria in 1997 to that in 1999?
Offer a terse response. 0.94. What is the ratio of the Unemployed and educated female labor force (% of population) in Cuba in 1997 to that in 1999?
Offer a very short reply. 1.1. What is the ratio of the Unemployed and educated female labor force (% of population) in Korea (Republic) in 1997 to that in 1999?
Provide a short and direct response. 0.73. What is the ratio of the Unemployed and educated female labor force (% of population) in Tunisia in 1997 to that in 1999?
Provide a succinct answer. 1.08. What is the ratio of the Unemployed and educated female labor force (% of population) of Bulgaria in 1997 to that in 2000?
Ensure brevity in your answer.  0.98. What is the ratio of the Unemployed and educated female labor force (% of population) in Korea (Republic) in 1997 to that in 2000?
Offer a very short reply. 0.77. What is the ratio of the Unemployed and educated female labor force (% of population) in Tunisia in 1997 to that in 2000?
Keep it short and to the point. 1.12. What is the ratio of the Unemployed and educated female labor force (% of population) of Bulgaria in 1997 to that in 2001?
Ensure brevity in your answer.  1.09. What is the ratio of the Unemployed and educated female labor force (% of population) in Cuba in 1997 to that in 2001?
Ensure brevity in your answer.  1.22. What is the ratio of the Unemployed and educated female labor force (% of population) in Korea (Republic) in 1997 to that in 2001?
Offer a very short reply. 0.89. What is the ratio of the Unemployed and educated female labor force (% of population) of Tunisia in 1997 to that in 2001?
Keep it short and to the point. 1.23. What is the ratio of the Unemployed and educated female labor force (% of population) in Bulgaria in 1997 to that in 2002?
Provide a short and direct response. 1.12. What is the ratio of the Unemployed and educated female labor force (% of population) in Cuba in 1997 to that in 2002?
Offer a terse response. 1.02. What is the ratio of the Unemployed and educated female labor force (% of population) in Korea (Republic) in 1997 to that in 2002?
Provide a succinct answer. 1. What is the ratio of the Unemployed and educated female labor force (% of population) of Tunisia in 1997 to that in 2002?
Provide a short and direct response. 1.28. What is the ratio of the Unemployed and educated female labor force (% of population) of Bulgaria in 1997 to that in 2003?
Your response must be concise. 1.13. What is the ratio of the Unemployed and educated female labor force (% of population) of Cuba in 1997 to that in 2003?
Your answer should be very brief. 1.22. What is the ratio of the Unemployed and educated female labor force (% of population) in Korea (Republic) in 1997 to that in 2003?
Your response must be concise. 1.2. What is the ratio of the Unemployed and educated female labor force (% of population) of Tunisia in 1997 to that in 2003?
Your response must be concise. 1.31. What is the ratio of the Unemployed and educated female labor force (% of population) of Bulgaria in 1997 to that in 2004?
Provide a short and direct response. 1.12. What is the ratio of the Unemployed and educated female labor force (% of population) of Cuba in 1997 to that in 2004?
Ensure brevity in your answer.  1.54. What is the ratio of the Unemployed and educated female labor force (% of population) of Korea (Republic) in 1997 to that in 2004?
Make the answer very short. 1.2. What is the ratio of the Unemployed and educated female labor force (% of population) in Tunisia in 1997 to that in 2004?
Keep it short and to the point. 1.3. What is the ratio of the Unemployed and educated female labor force (% of population) in Bulgaria in 1997 to that in 2005?
Offer a terse response. 1.08. What is the ratio of the Unemployed and educated female labor force (% of population) of Cuba in 1997 to that in 2005?
Offer a terse response. 1.11. What is the ratio of the Unemployed and educated female labor force (% of population) of Korea (Republic) in 1997 to that in 2005?
Provide a short and direct response. 1.3. What is the ratio of the Unemployed and educated female labor force (% of population) of Tunisia in 1997 to that in 2005?
Your answer should be compact. 1.5. What is the ratio of the Unemployed and educated female labor force (% of population) in Bulgaria in 1999 to that in 2000?
Make the answer very short. 1.05. What is the ratio of the Unemployed and educated female labor force (% of population) in Cuba in 1999 to that in 2000?
Offer a very short reply. 0.8. What is the ratio of the Unemployed and educated female labor force (% of population) in Korea (Republic) in 1999 to that in 2000?
Offer a very short reply. 1.06. What is the ratio of the Unemployed and educated female labor force (% of population) in Tunisia in 1999 to that in 2000?
Provide a succinct answer. 1.03. What is the ratio of the Unemployed and educated female labor force (% of population) in Cuba in 1999 to that in 2001?
Ensure brevity in your answer.  1.12. What is the ratio of the Unemployed and educated female labor force (% of population) of Korea (Republic) in 1999 to that in 2001?
Keep it short and to the point. 1.23. What is the ratio of the Unemployed and educated female labor force (% of population) in Tunisia in 1999 to that in 2001?
Give a very brief answer. 1.13. What is the ratio of the Unemployed and educated female labor force (% of population) of Bulgaria in 1999 to that in 2002?
Offer a very short reply. 1.2. What is the ratio of the Unemployed and educated female labor force (% of population) of Cuba in 1999 to that in 2002?
Provide a succinct answer. 0.94. What is the ratio of the Unemployed and educated female labor force (% of population) in Korea (Republic) in 1999 to that in 2002?
Offer a very short reply. 1.37. What is the ratio of the Unemployed and educated female labor force (% of population) in Tunisia in 1999 to that in 2002?
Ensure brevity in your answer.  1.18. What is the ratio of the Unemployed and educated female labor force (% of population) of Bulgaria in 1999 to that in 2003?
Your answer should be very brief. 1.21. What is the ratio of the Unemployed and educated female labor force (% of population) in Cuba in 1999 to that in 2003?
Provide a short and direct response. 1.12. What is the ratio of the Unemployed and educated female labor force (% of population) of Korea (Republic) in 1999 to that in 2003?
Your response must be concise. 1.66. What is the ratio of the Unemployed and educated female labor force (% of population) of Tunisia in 1999 to that in 2003?
Make the answer very short. 1.21. What is the ratio of the Unemployed and educated female labor force (% of population) in Bulgaria in 1999 to that in 2004?
Your response must be concise. 1.2. What is the ratio of the Unemployed and educated female labor force (% of population) of Cuba in 1999 to that in 2004?
Make the answer very short. 1.4. What is the ratio of the Unemployed and educated female labor force (% of population) of Korea (Republic) in 1999 to that in 2004?
Provide a short and direct response. 1.65. What is the ratio of the Unemployed and educated female labor force (% of population) of Tunisia in 1999 to that in 2004?
Your answer should be very brief. 1.2. What is the ratio of the Unemployed and educated female labor force (% of population) in Bulgaria in 1999 to that in 2005?
Give a very brief answer. 1.16. What is the ratio of the Unemployed and educated female labor force (% of population) in Cuba in 1999 to that in 2005?
Offer a very short reply. 1.02. What is the ratio of the Unemployed and educated female labor force (% of population) of Korea (Republic) in 1999 to that in 2005?
Keep it short and to the point. 1.78. What is the ratio of the Unemployed and educated female labor force (% of population) in Tunisia in 1999 to that in 2005?
Provide a succinct answer. 1.39. What is the ratio of the Unemployed and educated female labor force (% of population) of Bulgaria in 2000 to that in 2001?
Your response must be concise. 1.11. What is the ratio of the Unemployed and educated female labor force (% of population) in Cuba in 2000 to that in 2001?
Make the answer very short. 1.4. What is the ratio of the Unemployed and educated female labor force (% of population) of Korea (Republic) in 2000 to that in 2001?
Make the answer very short. 1.16. What is the ratio of the Unemployed and educated female labor force (% of population) in Tunisia in 2000 to that in 2001?
Give a very brief answer. 1.1. What is the ratio of the Unemployed and educated female labor force (% of population) of Bulgaria in 2000 to that in 2002?
Make the answer very short. 1.14. What is the ratio of the Unemployed and educated female labor force (% of population) of Cuba in 2000 to that in 2002?
Offer a very short reply. 1.17. What is the ratio of the Unemployed and educated female labor force (% of population) in Korea (Republic) in 2000 to that in 2002?
Give a very brief answer. 1.29. What is the ratio of the Unemployed and educated female labor force (% of population) of Tunisia in 2000 to that in 2002?
Provide a succinct answer. 1.14. What is the ratio of the Unemployed and educated female labor force (% of population) of Bulgaria in 2000 to that in 2003?
Provide a short and direct response. 1.15. What is the ratio of the Unemployed and educated female labor force (% of population) of Cuba in 2000 to that in 2003?
Offer a terse response. 1.4. What is the ratio of the Unemployed and educated female labor force (% of population) in Korea (Republic) in 2000 to that in 2003?
Give a very brief answer. 1.57. What is the ratio of the Unemployed and educated female labor force (% of population) in Tunisia in 2000 to that in 2003?
Keep it short and to the point. 1.17. What is the ratio of the Unemployed and educated female labor force (% of population) of Bulgaria in 2000 to that in 2004?
Give a very brief answer. 1.14. What is the ratio of the Unemployed and educated female labor force (% of population) of Cuba in 2000 to that in 2004?
Give a very brief answer. 1.76. What is the ratio of the Unemployed and educated female labor force (% of population) of Korea (Republic) in 2000 to that in 2004?
Provide a succinct answer. 1.56. What is the ratio of the Unemployed and educated female labor force (% of population) of Tunisia in 2000 to that in 2004?
Make the answer very short. 1.16. What is the ratio of the Unemployed and educated female labor force (% of population) in Bulgaria in 2000 to that in 2005?
Offer a very short reply. 1.1. What is the ratio of the Unemployed and educated female labor force (% of population) of Cuba in 2000 to that in 2005?
Ensure brevity in your answer.  1.27. What is the ratio of the Unemployed and educated female labor force (% of population) in Korea (Republic) in 2000 to that in 2005?
Your answer should be compact. 1.69. What is the ratio of the Unemployed and educated female labor force (% of population) in Tunisia in 2000 to that in 2005?
Provide a succinct answer. 1.34. What is the ratio of the Unemployed and educated female labor force (% of population) in Bulgaria in 2001 to that in 2002?
Provide a succinct answer. 1.03. What is the ratio of the Unemployed and educated female labor force (% of population) in Cuba in 2001 to that in 2002?
Provide a succinct answer. 0.84. What is the ratio of the Unemployed and educated female labor force (% of population) in Korea (Republic) in 2001 to that in 2002?
Offer a very short reply. 1.12. What is the ratio of the Unemployed and educated female labor force (% of population) of Tunisia in 2001 to that in 2002?
Your answer should be compact. 1.04. What is the ratio of the Unemployed and educated female labor force (% of population) in Bulgaria in 2001 to that in 2003?
Provide a short and direct response. 1.04. What is the ratio of the Unemployed and educated female labor force (% of population) in Korea (Republic) in 2001 to that in 2003?
Ensure brevity in your answer.  1.35. What is the ratio of the Unemployed and educated female labor force (% of population) in Tunisia in 2001 to that in 2003?
Provide a short and direct response. 1.07. What is the ratio of the Unemployed and educated female labor force (% of population) in Bulgaria in 2001 to that in 2004?
Offer a very short reply. 1.02. What is the ratio of the Unemployed and educated female labor force (% of population) in Cuba in 2001 to that in 2004?
Provide a succinct answer. 1.26. What is the ratio of the Unemployed and educated female labor force (% of population) of Korea (Republic) in 2001 to that in 2004?
Make the answer very short. 1.34. What is the ratio of the Unemployed and educated female labor force (% of population) of Tunisia in 2001 to that in 2004?
Ensure brevity in your answer.  1.06. What is the ratio of the Unemployed and educated female labor force (% of population) in Cuba in 2001 to that in 2005?
Offer a very short reply. 0.91. What is the ratio of the Unemployed and educated female labor force (% of population) in Korea (Republic) in 2001 to that in 2005?
Offer a terse response. 1.45. What is the ratio of the Unemployed and educated female labor force (% of population) in Tunisia in 2001 to that in 2005?
Your answer should be very brief. 1.22. What is the ratio of the Unemployed and educated female labor force (% of population) of Bulgaria in 2002 to that in 2003?
Keep it short and to the point. 1.01. What is the ratio of the Unemployed and educated female labor force (% of population) in Cuba in 2002 to that in 2003?
Keep it short and to the point. 1.19. What is the ratio of the Unemployed and educated female labor force (% of population) of Korea (Republic) in 2002 to that in 2003?
Give a very brief answer. 1.21. What is the ratio of the Unemployed and educated female labor force (% of population) of Tunisia in 2002 to that in 2003?
Ensure brevity in your answer.  1.02. What is the ratio of the Unemployed and educated female labor force (% of population) of Bulgaria in 2002 to that in 2004?
Your answer should be compact. 1. What is the ratio of the Unemployed and educated female labor force (% of population) of Cuba in 2002 to that in 2004?
Offer a very short reply. 1.5. What is the ratio of the Unemployed and educated female labor force (% of population) of Korea (Republic) in 2002 to that in 2004?
Offer a terse response. 1.2. What is the ratio of the Unemployed and educated female labor force (% of population) in Tunisia in 2002 to that in 2004?
Give a very brief answer. 1.02. What is the ratio of the Unemployed and educated female labor force (% of population) of Bulgaria in 2002 to that in 2005?
Offer a terse response. 0.96. What is the ratio of the Unemployed and educated female labor force (% of population) in Cuba in 2002 to that in 2005?
Your answer should be compact. 1.09. What is the ratio of the Unemployed and educated female labor force (% of population) in Korea (Republic) in 2002 to that in 2005?
Your answer should be compact. 1.3. What is the ratio of the Unemployed and educated female labor force (% of population) of Tunisia in 2002 to that in 2005?
Offer a terse response. 1.17. What is the ratio of the Unemployed and educated female labor force (% of population) in Cuba in 2003 to that in 2004?
Offer a terse response. 1.26. What is the ratio of the Unemployed and educated female labor force (% of population) in Tunisia in 2003 to that in 2004?
Your answer should be very brief. 0.99. What is the ratio of the Unemployed and educated female labor force (% of population) of Bulgaria in 2003 to that in 2005?
Your answer should be very brief. 0.96. What is the ratio of the Unemployed and educated female labor force (% of population) of Cuba in 2003 to that in 2005?
Provide a succinct answer. 0.91. What is the ratio of the Unemployed and educated female labor force (% of population) in Korea (Republic) in 2003 to that in 2005?
Your answer should be very brief. 1.08. What is the ratio of the Unemployed and educated female labor force (% of population) in Tunisia in 2003 to that in 2005?
Your answer should be very brief. 1.14. What is the ratio of the Unemployed and educated female labor force (% of population) of Bulgaria in 2004 to that in 2005?
Make the answer very short. 0.97. What is the ratio of the Unemployed and educated female labor force (% of population) in Cuba in 2004 to that in 2005?
Give a very brief answer. 0.73. What is the ratio of the Unemployed and educated female labor force (% of population) in Korea (Republic) in 2004 to that in 2005?
Keep it short and to the point. 1.08. What is the ratio of the Unemployed and educated female labor force (% of population) of Tunisia in 2004 to that in 2005?
Offer a very short reply. 1.15. What is the difference between the highest and the second highest Unemployed and educated female labor force (% of population) in Bulgaria?
Keep it short and to the point. 1.9. What is the difference between the highest and the second highest Unemployed and educated female labor force (% of population) of Korea (Republic)?
Your answer should be very brief. 1.5. What is the difference between the highest and the second highest Unemployed and educated female labor force (% of population) in Tunisia?
Ensure brevity in your answer.  3.6. What is the difference between the highest and the lowest Unemployed and educated female labor force (% of population) of Cuba?
Provide a succinct answer. 6.2. 